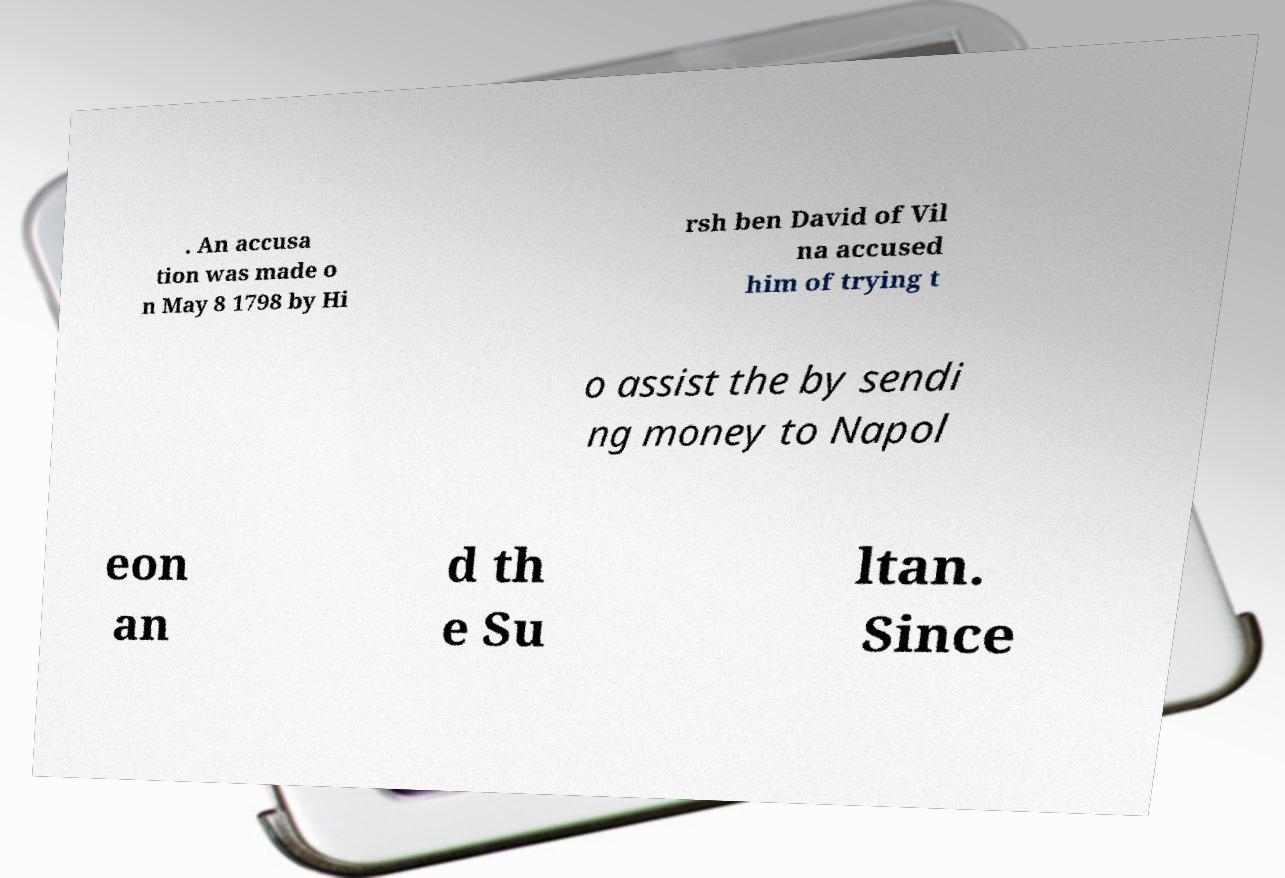Please read and relay the text visible in this image. What does it say? . An accusa tion was made o n May 8 1798 by Hi rsh ben David of Vil na accused him of trying t o assist the by sendi ng money to Napol eon an d th e Su ltan. Since 